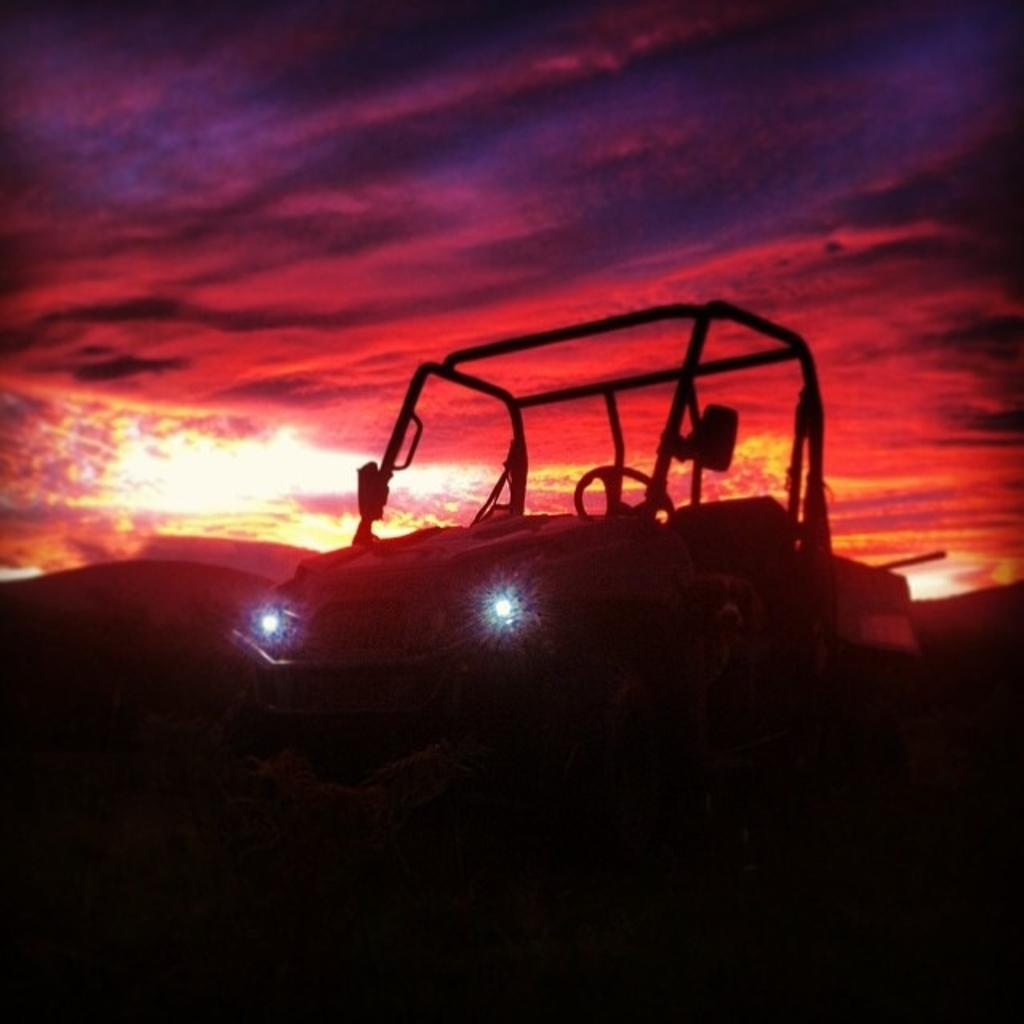What is the main subject of the picture? The main subject of the picture is a vehicle. What color is the vehicle? The vehicle is black in color. What can be seen in the background of the picture? The sky is visible in the background of the picture. What color is the sky? The sky is red in color. How many snails can be seen crawling on the vehicle in the image? There are no snails present in the image; it features a black vehicle with a red sky in the background. What type of pail is being used by the boys in the image? There are no boys or pails present in the image. 